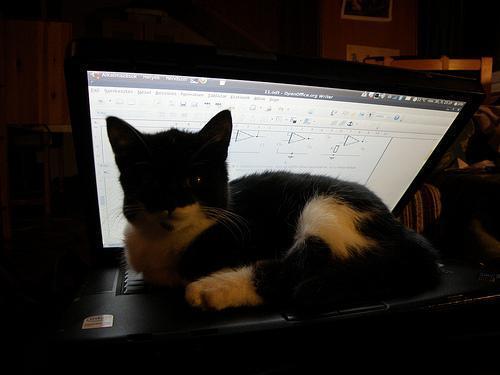How many cats are there?
Give a very brief answer. 1. 